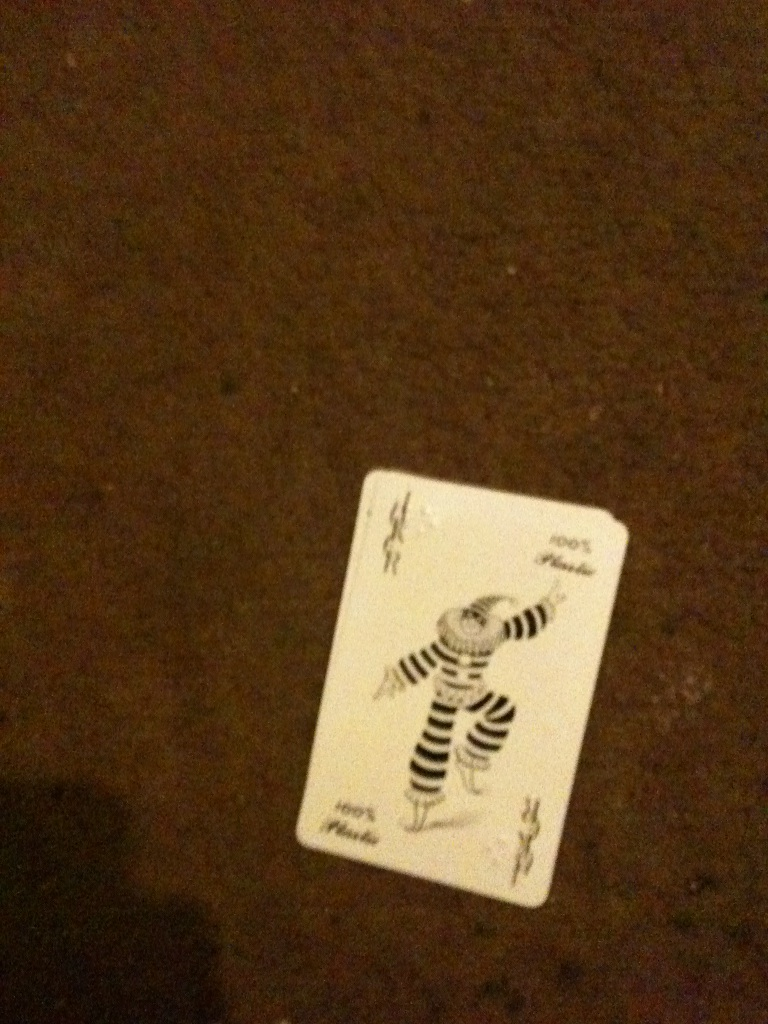Can you please tell me what card this is? This is a 'Joker' card. Typically, the Joker is a special card found in most modern card decks and can often be used as a wild card in various games. The artwork on this particular Joker features a whimsical character dressed in striped attire, which adds a touch of humor and uniqueness to the card. 